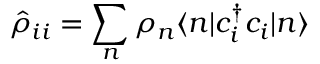Convert formula to latex. <formula><loc_0><loc_0><loc_500><loc_500>\hat { \rho } _ { i i } = \sum _ { n } \rho _ { n } \langle n | c _ { i } ^ { \dagger } c _ { i } | n \rangle</formula> 